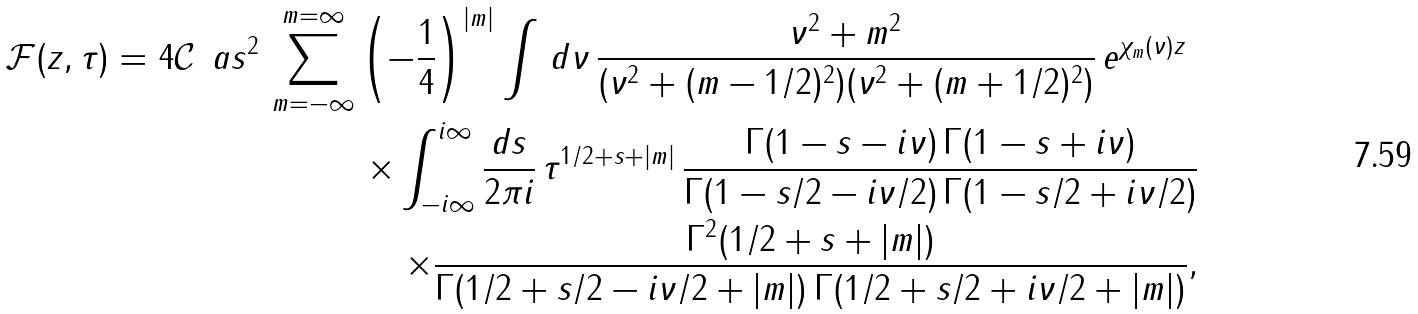Convert formula to latex. <formula><loc_0><loc_0><loc_500><loc_500>\mathcal { F } ( z , \tau ) = 4 \mathcal { C } \, \ a s ^ { 2 } \, \sum _ { m = - \infty } ^ { m = \infty } \left ( - \frac { 1 } { 4 } \right ) ^ { | m | } \int \, d \nu \, \frac { \nu ^ { 2 } + m ^ { 2 } } { ( \nu ^ { 2 } + ( m - 1 / 2 ) ^ { 2 } ) ( \nu ^ { 2 } + ( m + 1 / 2 ) ^ { 2 } ) } \, e ^ { \chi _ { m } ( \nu ) z } \ \\ \times \int _ { - i \infty } ^ { i \infty } \frac { d s } { 2 \pi i } \, \tau ^ { 1 / 2 + s + | m | } \, \frac { \Gamma ( 1 - s - i \nu ) \, \Gamma ( 1 - s + i \nu ) } { \Gamma ( 1 - s / 2 - i \nu / 2 ) \, \Gamma ( 1 - s / 2 + i \nu / 2 ) } \\ \times \frac { \Gamma ^ { 2 } ( 1 / 2 + s + | m | ) } { \Gamma ( 1 / 2 + s / 2 - i \nu / 2 + | m | ) \, \Gamma ( 1 / 2 + s / 2 + i \nu / 2 + | m | ) } ,</formula> 